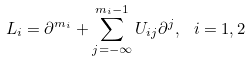Convert formula to latex. <formula><loc_0><loc_0><loc_500><loc_500>L _ { i } = \partial ^ { m _ { i } } + \sum _ { j = - \infty } ^ { m _ { i } - 1 } U _ { i j } \partial ^ { j } , \ i = 1 , 2</formula> 